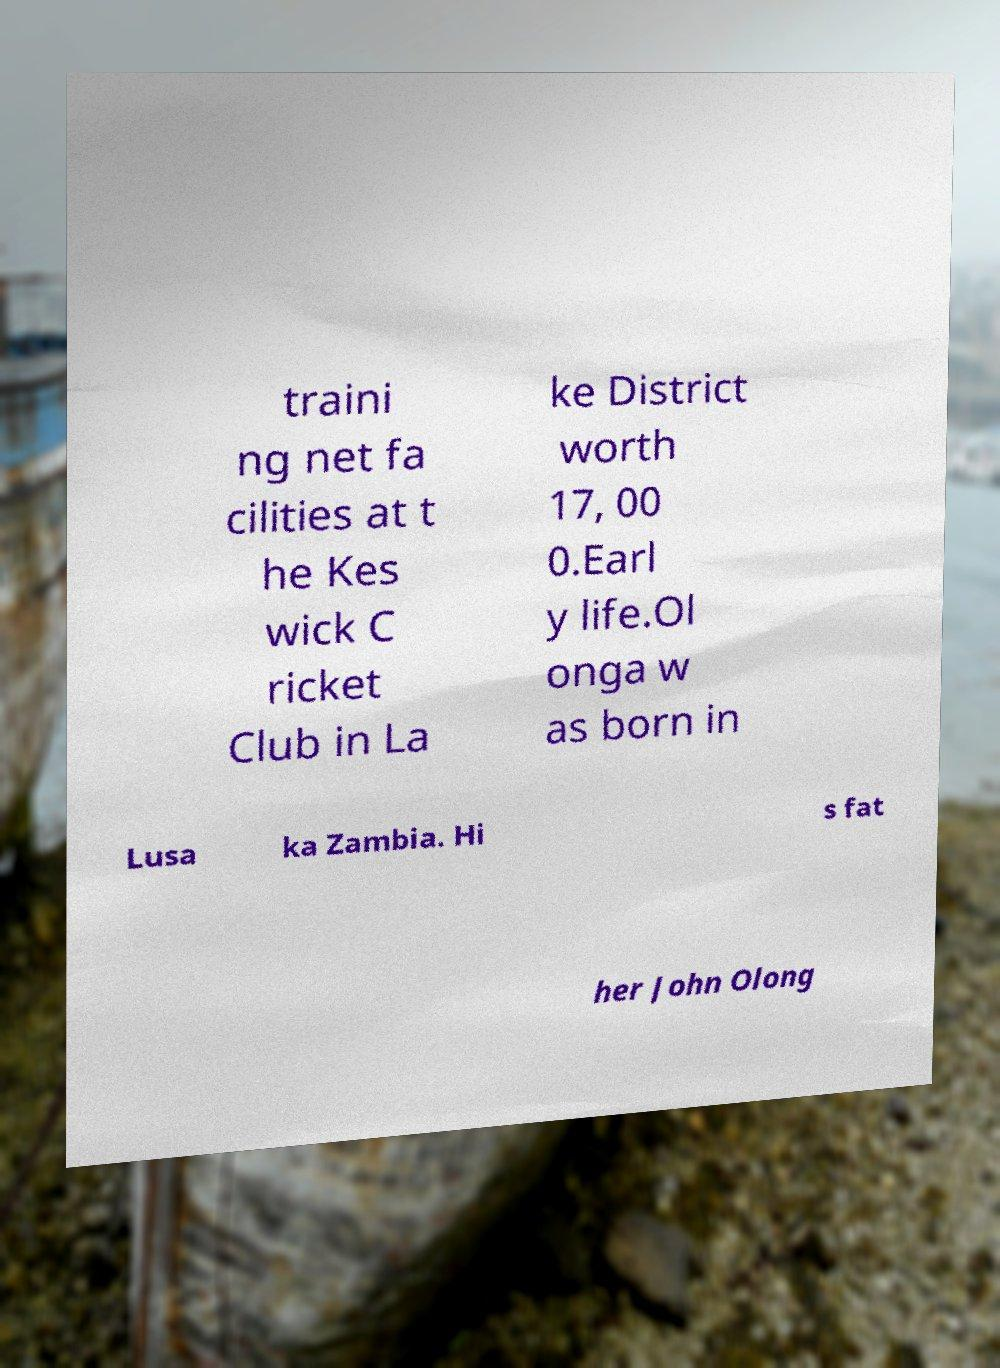I need the written content from this picture converted into text. Can you do that? traini ng net fa cilities at t he Kes wick C ricket Club in La ke District worth 17, 00 0.Earl y life.Ol onga w as born in Lusa ka Zambia. Hi s fat her John Olong 